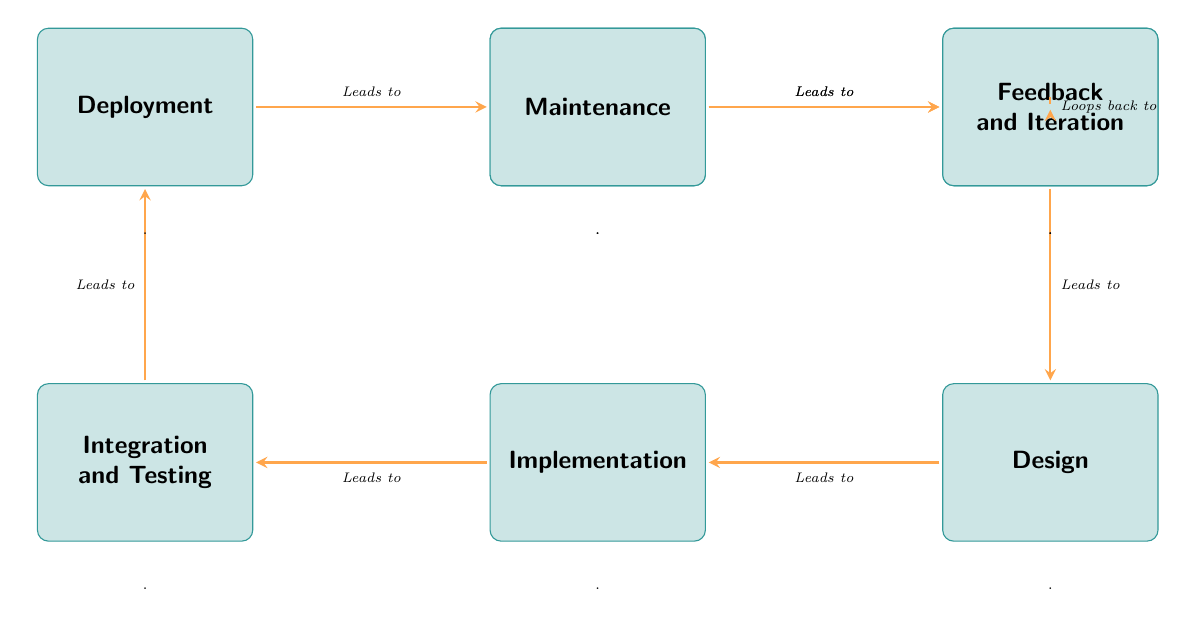What is the first step in the software development process? The first step in the diagram is labeled "Idea Conception," which is the starting point of the development process.
Answer: Idea Conception How many steps are there in the software development lifecycle depicted in the diagram? The diagram shows a total of eight steps from "Idea Conception" to "Feedback and Iteration."
Answer: Eight What step comes after Design? The diagram indicates that "Implementation" is the step immediately following "Design."
Answer: Implementation Which step leads to Maintenance? According to the diagram, "Deployment" is the step that leads to "Maintenance."
Answer: Deployment What action is represented by the arrow from Feedback and Iteration? The arrow from "Feedback and Iteration" loops back to "Requirement Analysis," indicating a review process that feeds back into earlier stages.
Answer: Loops back to Requirement Analysis How many edges are shown in the diagram? There are a total of seven directed edges shown since each step leads to the next, culminating in the loop back to a previous step.
Answer: Seven Which two steps are adjacent to Integration and Testing? "Implementation" is to the left and "Deployment" is below "Integration and Testing," making them the two adjacent steps.
Answer: Implementation and Deployment What is the relationship between Requirement Analysis and Design? The arrow indicates that "Requirement Analysis" leads to "Design," establishing a direct relationship where one step influences the subsequent step.
Answer: Leads to What does the arrow from Idea Conception indicate? The arrow signifies that "Idea Conception" leads directly to "Requirement Analysis," showing the progression from initial thought to structured requirements.
Answer: Leads to Requirement Analysis 